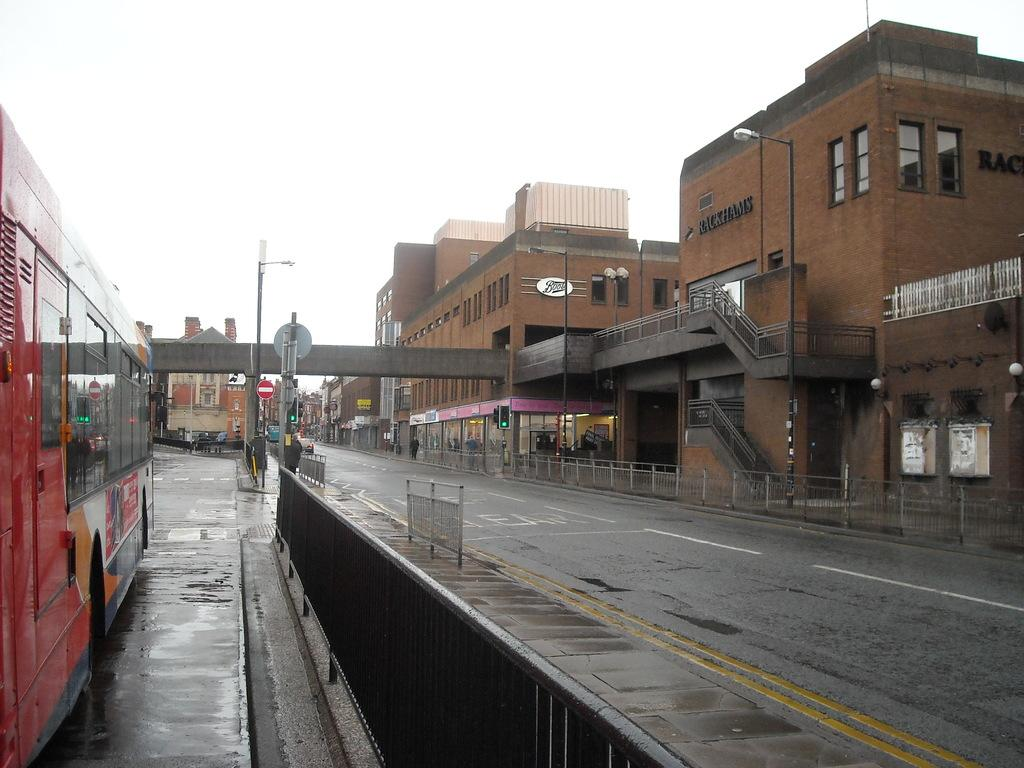<image>
Present a compact description of the photo's key features. an almost empty street next to a Rackham's building 